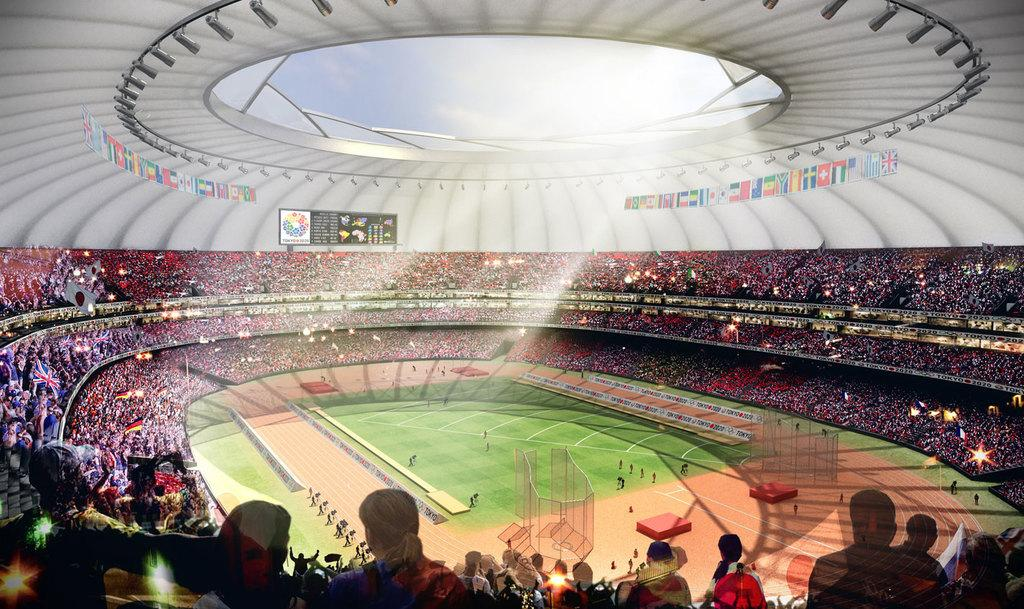How many people are in the image? There is a group of people in the image, but the exact number cannot be determined from the provided facts. Where are some of the people located in the image? Some people are on a stage in the image. What can be seen in the image besides people? There are flags, a scoreboard, a roof, and objects in the image. What is visible in the background of the image? The sky is visible in the background of the image. What type of tooth is visible in the image? There is no tooth present in the image. How does the dock affect the group of people in the image? There is no dock present in the image, so it cannot affect the group of people. 